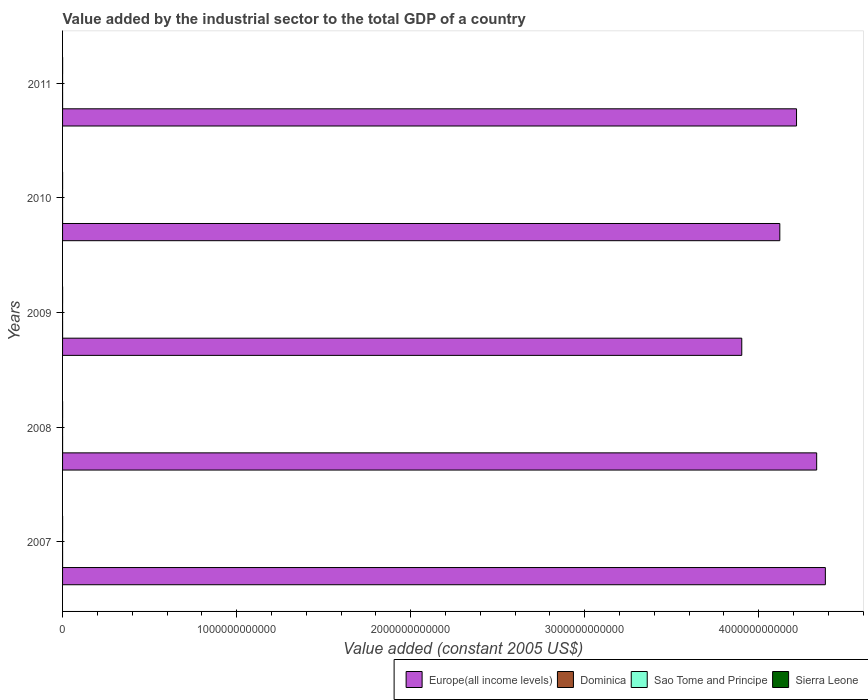How many different coloured bars are there?
Keep it short and to the point. 4. How many groups of bars are there?
Make the answer very short. 5. Are the number of bars per tick equal to the number of legend labels?
Make the answer very short. Yes. How many bars are there on the 3rd tick from the top?
Your response must be concise. 4. What is the label of the 4th group of bars from the top?
Your response must be concise. 2008. In how many cases, is the number of bars for a given year not equal to the number of legend labels?
Offer a terse response. 0. What is the value added by the industrial sector in Sao Tome and Principe in 2007?
Ensure brevity in your answer.  2.07e+07. Across all years, what is the maximum value added by the industrial sector in Europe(all income levels)?
Your answer should be compact. 4.38e+12. Across all years, what is the minimum value added by the industrial sector in Sao Tome and Principe?
Your response must be concise. 2.07e+07. In which year was the value added by the industrial sector in Europe(all income levels) maximum?
Offer a very short reply. 2007. In which year was the value added by the industrial sector in Dominica minimum?
Make the answer very short. 2009. What is the total value added by the industrial sector in Sierra Leone in the graph?
Offer a very short reply. 9.48e+08. What is the difference between the value added by the industrial sector in Europe(all income levels) in 2008 and that in 2011?
Give a very brief answer. 1.16e+11. What is the difference between the value added by the industrial sector in Europe(all income levels) in 2009 and the value added by the industrial sector in Dominica in 2008?
Keep it short and to the point. 3.90e+12. What is the average value added by the industrial sector in Europe(all income levels) per year?
Provide a succinct answer. 4.19e+12. In the year 2008, what is the difference between the value added by the industrial sector in Sao Tome and Principe and value added by the industrial sector in Sierra Leone?
Keep it short and to the point. -1.58e+08. What is the ratio of the value added by the industrial sector in Sao Tome and Principe in 2009 to that in 2010?
Your answer should be very brief. 0.98. Is the value added by the industrial sector in Sierra Leone in 2008 less than that in 2011?
Your response must be concise. Yes. What is the difference between the highest and the second highest value added by the industrial sector in Europe(all income levels)?
Your answer should be compact. 4.99e+1. What is the difference between the highest and the lowest value added by the industrial sector in Dominica?
Make the answer very short. 4.72e+06. In how many years, is the value added by the industrial sector in Europe(all income levels) greater than the average value added by the industrial sector in Europe(all income levels) taken over all years?
Give a very brief answer. 3. What does the 4th bar from the top in 2008 represents?
Your answer should be very brief. Europe(all income levels). What does the 4th bar from the bottom in 2008 represents?
Your answer should be compact. Sierra Leone. Is it the case that in every year, the sum of the value added by the industrial sector in Sao Tome and Principe and value added by the industrial sector in Europe(all income levels) is greater than the value added by the industrial sector in Sierra Leone?
Provide a short and direct response. Yes. How many bars are there?
Your response must be concise. 20. What is the difference between two consecutive major ticks on the X-axis?
Offer a terse response. 1.00e+12. Does the graph contain grids?
Give a very brief answer. No. Where does the legend appear in the graph?
Your response must be concise. Bottom right. How are the legend labels stacked?
Provide a succinct answer. Horizontal. What is the title of the graph?
Your response must be concise. Value added by the industrial sector to the total GDP of a country. Does "Barbados" appear as one of the legend labels in the graph?
Your response must be concise. No. What is the label or title of the X-axis?
Keep it short and to the point. Value added (constant 2005 US$). What is the label or title of the Y-axis?
Provide a short and direct response. Years. What is the Value added (constant 2005 US$) of Europe(all income levels) in 2007?
Your response must be concise. 4.38e+12. What is the Value added (constant 2005 US$) in Dominica in 2007?
Provide a succinct answer. 5.39e+07. What is the Value added (constant 2005 US$) of Sao Tome and Principe in 2007?
Your answer should be compact. 2.07e+07. What is the Value added (constant 2005 US$) of Sierra Leone in 2007?
Make the answer very short. 2.01e+08. What is the Value added (constant 2005 US$) of Europe(all income levels) in 2008?
Your response must be concise. 4.33e+12. What is the Value added (constant 2005 US$) in Dominica in 2008?
Your response must be concise. 5.82e+07. What is the Value added (constant 2005 US$) of Sao Tome and Principe in 2008?
Keep it short and to the point. 2.19e+07. What is the Value added (constant 2005 US$) of Sierra Leone in 2008?
Provide a succinct answer. 1.80e+08. What is the Value added (constant 2005 US$) of Europe(all income levels) in 2009?
Your response must be concise. 3.90e+12. What is the Value added (constant 2005 US$) in Dominica in 2009?
Your response must be concise. 5.35e+07. What is the Value added (constant 2005 US$) of Sao Tome and Principe in 2009?
Your response must be concise. 2.21e+07. What is the Value added (constant 2005 US$) of Sierra Leone in 2009?
Your response must be concise. 1.69e+08. What is the Value added (constant 2005 US$) in Europe(all income levels) in 2010?
Keep it short and to the point. 4.12e+12. What is the Value added (constant 2005 US$) in Dominica in 2010?
Offer a very short reply. 5.51e+07. What is the Value added (constant 2005 US$) of Sao Tome and Principe in 2010?
Your answer should be compact. 2.26e+07. What is the Value added (constant 2005 US$) in Sierra Leone in 2010?
Offer a very short reply. 1.89e+08. What is the Value added (constant 2005 US$) of Europe(all income levels) in 2011?
Your answer should be very brief. 4.22e+12. What is the Value added (constant 2005 US$) of Dominica in 2011?
Your answer should be very brief. 5.50e+07. What is the Value added (constant 2005 US$) in Sao Tome and Principe in 2011?
Offer a terse response. 2.38e+07. What is the Value added (constant 2005 US$) of Sierra Leone in 2011?
Ensure brevity in your answer.  2.09e+08. Across all years, what is the maximum Value added (constant 2005 US$) of Europe(all income levels)?
Keep it short and to the point. 4.38e+12. Across all years, what is the maximum Value added (constant 2005 US$) of Dominica?
Offer a very short reply. 5.82e+07. Across all years, what is the maximum Value added (constant 2005 US$) of Sao Tome and Principe?
Provide a succinct answer. 2.38e+07. Across all years, what is the maximum Value added (constant 2005 US$) in Sierra Leone?
Your response must be concise. 2.09e+08. Across all years, what is the minimum Value added (constant 2005 US$) of Europe(all income levels)?
Your answer should be compact. 3.90e+12. Across all years, what is the minimum Value added (constant 2005 US$) in Dominica?
Provide a succinct answer. 5.35e+07. Across all years, what is the minimum Value added (constant 2005 US$) of Sao Tome and Principe?
Keep it short and to the point. 2.07e+07. Across all years, what is the minimum Value added (constant 2005 US$) of Sierra Leone?
Give a very brief answer. 1.69e+08. What is the total Value added (constant 2005 US$) of Europe(all income levels) in the graph?
Offer a terse response. 2.10e+13. What is the total Value added (constant 2005 US$) of Dominica in the graph?
Offer a very short reply. 2.76e+08. What is the total Value added (constant 2005 US$) in Sao Tome and Principe in the graph?
Your answer should be compact. 1.11e+08. What is the total Value added (constant 2005 US$) in Sierra Leone in the graph?
Keep it short and to the point. 9.48e+08. What is the difference between the Value added (constant 2005 US$) of Europe(all income levels) in 2007 and that in 2008?
Offer a terse response. 4.99e+1. What is the difference between the Value added (constant 2005 US$) of Dominica in 2007 and that in 2008?
Offer a very short reply. -4.34e+06. What is the difference between the Value added (constant 2005 US$) of Sao Tome and Principe in 2007 and that in 2008?
Provide a succinct answer. -1.21e+06. What is the difference between the Value added (constant 2005 US$) in Sierra Leone in 2007 and that in 2008?
Give a very brief answer. 2.08e+07. What is the difference between the Value added (constant 2005 US$) in Europe(all income levels) in 2007 and that in 2009?
Make the answer very short. 4.80e+11. What is the difference between the Value added (constant 2005 US$) in Dominica in 2007 and that in 2009?
Provide a short and direct response. 3.71e+05. What is the difference between the Value added (constant 2005 US$) of Sao Tome and Principe in 2007 and that in 2009?
Give a very brief answer. -1.36e+06. What is the difference between the Value added (constant 2005 US$) of Sierra Leone in 2007 and that in 2009?
Make the answer very short. 3.24e+07. What is the difference between the Value added (constant 2005 US$) of Europe(all income levels) in 2007 and that in 2010?
Offer a very short reply. 2.62e+11. What is the difference between the Value added (constant 2005 US$) of Dominica in 2007 and that in 2010?
Offer a very short reply. -1.17e+06. What is the difference between the Value added (constant 2005 US$) of Sao Tome and Principe in 2007 and that in 2010?
Offer a terse response. -1.87e+06. What is the difference between the Value added (constant 2005 US$) in Sierra Leone in 2007 and that in 2010?
Offer a terse response. 1.17e+07. What is the difference between the Value added (constant 2005 US$) of Europe(all income levels) in 2007 and that in 2011?
Your answer should be compact. 1.66e+11. What is the difference between the Value added (constant 2005 US$) of Dominica in 2007 and that in 2011?
Offer a terse response. -1.12e+06. What is the difference between the Value added (constant 2005 US$) of Sao Tome and Principe in 2007 and that in 2011?
Make the answer very short. -3.09e+06. What is the difference between the Value added (constant 2005 US$) of Sierra Leone in 2007 and that in 2011?
Keep it short and to the point. -7.69e+06. What is the difference between the Value added (constant 2005 US$) of Europe(all income levels) in 2008 and that in 2009?
Your answer should be compact. 4.30e+11. What is the difference between the Value added (constant 2005 US$) in Dominica in 2008 and that in 2009?
Your answer should be compact. 4.72e+06. What is the difference between the Value added (constant 2005 US$) of Sao Tome and Principe in 2008 and that in 2009?
Make the answer very short. -1.52e+05. What is the difference between the Value added (constant 2005 US$) in Sierra Leone in 2008 and that in 2009?
Your answer should be very brief. 1.16e+07. What is the difference between the Value added (constant 2005 US$) in Europe(all income levels) in 2008 and that in 2010?
Your answer should be compact. 2.12e+11. What is the difference between the Value added (constant 2005 US$) in Dominica in 2008 and that in 2010?
Your answer should be compact. 3.18e+06. What is the difference between the Value added (constant 2005 US$) in Sao Tome and Principe in 2008 and that in 2010?
Provide a short and direct response. -6.63e+05. What is the difference between the Value added (constant 2005 US$) in Sierra Leone in 2008 and that in 2010?
Provide a succinct answer. -9.16e+06. What is the difference between the Value added (constant 2005 US$) in Europe(all income levels) in 2008 and that in 2011?
Your answer should be compact. 1.16e+11. What is the difference between the Value added (constant 2005 US$) in Dominica in 2008 and that in 2011?
Your response must be concise. 3.23e+06. What is the difference between the Value added (constant 2005 US$) in Sao Tome and Principe in 2008 and that in 2011?
Offer a very short reply. -1.88e+06. What is the difference between the Value added (constant 2005 US$) of Sierra Leone in 2008 and that in 2011?
Offer a very short reply. -2.85e+07. What is the difference between the Value added (constant 2005 US$) of Europe(all income levels) in 2009 and that in 2010?
Make the answer very short. -2.19e+11. What is the difference between the Value added (constant 2005 US$) of Dominica in 2009 and that in 2010?
Your response must be concise. -1.54e+06. What is the difference between the Value added (constant 2005 US$) of Sao Tome and Principe in 2009 and that in 2010?
Offer a very short reply. -5.12e+05. What is the difference between the Value added (constant 2005 US$) in Sierra Leone in 2009 and that in 2010?
Make the answer very short. -2.08e+07. What is the difference between the Value added (constant 2005 US$) in Europe(all income levels) in 2009 and that in 2011?
Provide a succinct answer. -3.15e+11. What is the difference between the Value added (constant 2005 US$) in Dominica in 2009 and that in 2011?
Offer a very short reply. -1.49e+06. What is the difference between the Value added (constant 2005 US$) of Sao Tome and Principe in 2009 and that in 2011?
Make the answer very short. -1.72e+06. What is the difference between the Value added (constant 2005 US$) of Sierra Leone in 2009 and that in 2011?
Ensure brevity in your answer.  -4.01e+07. What is the difference between the Value added (constant 2005 US$) in Europe(all income levels) in 2010 and that in 2011?
Offer a very short reply. -9.60e+1. What is the difference between the Value added (constant 2005 US$) in Dominica in 2010 and that in 2011?
Provide a succinct answer. 5.16e+04. What is the difference between the Value added (constant 2005 US$) in Sao Tome and Principe in 2010 and that in 2011?
Your answer should be very brief. -1.21e+06. What is the difference between the Value added (constant 2005 US$) in Sierra Leone in 2010 and that in 2011?
Keep it short and to the point. -1.94e+07. What is the difference between the Value added (constant 2005 US$) in Europe(all income levels) in 2007 and the Value added (constant 2005 US$) in Dominica in 2008?
Make the answer very short. 4.38e+12. What is the difference between the Value added (constant 2005 US$) of Europe(all income levels) in 2007 and the Value added (constant 2005 US$) of Sao Tome and Principe in 2008?
Offer a very short reply. 4.38e+12. What is the difference between the Value added (constant 2005 US$) in Europe(all income levels) in 2007 and the Value added (constant 2005 US$) in Sierra Leone in 2008?
Your answer should be compact. 4.38e+12. What is the difference between the Value added (constant 2005 US$) in Dominica in 2007 and the Value added (constant 2005 US$) in Sao Tome and Principe in 2008?
Offer a terse response. 3.20e+07. What is the difference between the Value added (constant 2005 US$) of Dominica in 2007 and the Value added (constant 2005 US$) of Sierra Leone in 2008?
Make the answer very short. -1.26e+08. What is the difference between the Value added (constant 2005 US$) in Sao Tome and Principe in 2007 and the Value added (constant 2005 US$) in Sierra Leone in 2008?
Keep it short and to the point. -1.59e+08. What is the difference between the Value added (constant 2005 US$) in Europe(all income levels) in 2007 and the Value added (constant 2005 US$) in Dominica in 2009?
Your answer should be very brief. 4.38e+12. What is the difference between the Value added (constant 2005 US$) in Europe(all income levels) in 2007 and the Value added (constant 2005 US$) in Sao Tome and Principe in 2009?
Offer a terse response. 4.38e+12. What is the difference between the Value added (constant 2005 US$) in Europe(all income levels) in 2007 and the Value added (constant 2005 US$) in Sierra Leone in 2009?
Provide a succinct answer. 4.38e+12. What is the difference between the Value added (constant 2005 US$) in Dominica in 2007 and the Value added (constant 2005 US$) in Sao Tome and Principe in 2009?
Offer a terse response. 3.18e+07. What is the difference between the Value added (constant 2005 US$) in Dominica in 2007 and the Value added (constant 2005 US$) in Sierra Leone in 2009?
Your answer should be very brief. -1.15e+08. What is the difference between the Value added (constant 2005 US$) of Sao Tome and Principe in 2007 and the Value added (constant 2005 US$) of Sierra Leone in 2009?
Provide a short and direct response. -1.48e+08. What is the difference between the Value added (constant 2005 US$) of Europe(all income levels) in 2007 and the Value added (constant 2005 US$) of Dominica in 2010?
Your answer should be compact. 4.38e+12. What is the difference between the Value added (constant 2005 US$) of Europe(all income levels) in 2007 and the Value added (constant 2005 US$) of Sao Tome and Principe in 2010?
Offer a very short reply. 4.38e+12. What is the difference between the Value added (constant 2005 US$) of Europe(all income levels) in 2007 and the Value added (constant 2005 US$) of Sierra Leone in 2010?
Provide a succinct answer. 4.38e+12. What is the difference between the Value added (constant 2005 US$) in Dominica in 2007 and the Value added (constant 2005 US$) in Sao Tome and Principe in 2010?
Offer a terse response. 3.13e+07. What is the difference between the Value added (constant 2005 US$) of Dominica in 2007 and the Value added (constant 2005 US$) of Sierra Leone in 2010?
Keep it short and to the point. -1.35e+08. What is the difference between the Value added (constant 2005 US$) of Sao Tome and Principe in 2007 and the Value added (constant 2005 US$) of Sierra Leone in 2010?
Your response must be concise. -1.69e+08. What is the difference between the Value added (constant 2005 US$) in Europe(all income levels) in 2007 and the Value added (constant 2005 US$) in Dominica in 2011?
Provide a succinct answer. 4.38e+12. What is the difference between the Value added (constant 2005 US$) in Europe(all income levels) in 2007 and the Value added (constant 2005 US$) in Sao Tome and Principe in 2011?
Provide a short and direct response. 4.38e+12. What is the difference between the Value added (constant 2005 US$) of Europe(all income levels) in 2007 and the Value added (constant 2005 US$) of Sierra Leone in 2011?
Offer a terse response. 4.38e+12. What is the difference between the Value added (constant 2005 US$) of Dominica in 2007 and the Value added (constant 2005 US$) of Sao Tome and Principe in 2011?
Offer a terse response. 3.01e+07. What is the difference between the Value added (constant 2005 US$) of Dominica in 2007 and the Value added (constant 2005 US$) of Sierra Leone in 2011?
Your answer should be compact. -1.55e+08. What is the difference between the Value added (constant 2005 US$) of Sao Tome and Principe in 2007 and the Value added (constant 2005 US$) of Sierra Leone in 2011?
Your answer should be compact. -1.88e+08. What is the difference between the Value added (constant 2005 US$) of Europe(all income levels) in 2008 and the Value added (constant 2005 US$) of Dominica in 2009?
Your response must be concise. 4.33e+12. What is the difference between the Value added (constant 2005 US$) of Europe(all income levels) in 2008 and the Value added (constant 2005 US$) of Sao Tome and Principe in 2009?
Give a very brief answer. 4.33e+12. What is the difference between the Value added (constant 2005 US$) of Europe(all income levels) in 2008 and the Value added (constant 2005 US$) of Sierra Leone in 2009?
Ensure brevity in your answer.  4.33e+12. What is the difference between the Value added (constant 2005 US$) of Dominica in 2008 and the Value added (constant 2005 US$) of Sao Tome and Principe in 2009?
Provide a short and direct response. 3.62e+07. What is the difference between the Value added (constant 2005 US$) in Dominica in 2008 and the Value added (constant 2005 US$) in Sierra Leone in 2009?
Offer a terse response. -1.10e+08. What is the difference between the Value added (constant 2005 US$) of Sao Tome and Principe in 2008 and the Value added (constant 2005 US$) of Sierra Leone in 2009?
Keep it short and to the point. -1.47e+08. What is the difference between the Value added (constant 2005 US$) in Europe(all income levels) in 2008 and the Value added (constant 2005 US$) in Dominica in 2010?
Provide a short and direct response. 4.33e+12. What is the difference between the Value added (constant 2005 US$) in Europe(all income levels) in 2008 and the Value added (constant 2005 US$) in Sao Tome and Principe in 2010?
Your response must be concise. 4.33e+12. What is the difference between the Value added (constant 2005 US$) in Europe(all income levels) in 2008 and the Value added (constant 2005 US$) in Sierra Leone in 2010?
Keep it short and to the point. 4.33e+12. What is the difference between the Value added (constant 2005 US$) of Dominica in 2008 and the Value added (constant 2005 US$) of Sao Tome and Principe in 2010?
Make the answer very short. 3.57e+07. What is the difference between the Value added (constant 2005 US$) of Dominica in 2008 and the Value added (constant 2005 US$) of Sierra Leone in 2010?
Make the answer very short. -1.31e+08. What is the difference between the Value added (constant 2005 US$) in Sao Tome and Principe in 2008 and the Value added (constant 2005 US$) in Sierra Leone in 2010?
Provide a short and direct response. -1.67e+08. What is the difference between the Value added (constant 2005 US$) in Europe(all income levels) in 2008 and the Value added (constant 2005 US$) in Dominica in 2011?
Offer a very short reply. 4.33e+12. What is the difference between the Value added (constant 2005 US$) in Europe(all income levels) in 2008 and the Value added (constant 2005 US$) in Sao Tome and Principe in 2011?
Provide a succinct answer. 4.33e+12. What is the difference between the Value added (constant 2005 US$) of Europe(all income levels) in 2008 and the Value added (constant 2005 US$) of Sierra Leone in 2011?
Your answer should be compact. 4.33e+12. What is the difference between the Value added (constant 2005 US$) of Dominica in 2008 and the Value added (constant 2005 US$) of Sao Tome and Principe in 2011?
Provide a short and direct response. 3.44e+07. What is the difference between the Value added (constant 2005 US$) in Dominica in 2008 and the Value added (constant 2005 US$) in Sierra Leone in 2011?
Make the answer very short. -1.50e+08. What is the difference between the Value added (constant 2005 US$) of Sao Tome and Principe in 2008 and the Value added (constant 2005 US$) of Sierra Leone in 2011?
Your response must be concise. -1.87e+08. What is the difference between the Value added (constant 2005 US$) in Europe(all income levels) in 2009 and the Value added (constant 2005 US$) in Dominica in 2010?
Keep it short and to the point. 3.90e+12. What is the difference between the Value added (constant 2005 US$) of Europe(all income levels) in 2009 and the Value added (constant 2005 US$) of Sao Tome and Principe in 2010?
Keep it short and to the point. 3.90e+12. What is the difference between the Value added (constant 2005 US$) of Europe(all income levels) in 2009 and the Value added (constant 2005 US$) of Sierra Leone in 2010?
Your response must be concise. 3.90e+12. What is the difference between the Value added (constant 2005 US$) of Dominica in 2009 and the Value added (constant 2005 US$) of Sao Tome and Principe in 2010?
Provide a short and direct response. 3.09e+07. What is the difference between the Value added (constant 2005 US$) of Dominica in 2009 and the Value added (constant 2005 US$) of Sierra Leone in 2010?
Your answer should be very brief. -1.36e+08. What is the difference between the Value added (constant 2005 US$) of Sao Tome and Principe in 2009 and the Value added (constant 2005 US$) of Sierra Leone in 2010?
Your answer should be compact. -1.67e+08. What is the difference between the Value added (constant 2005 US$) of Europe(all income levels) in 2009 and the Value added (constant 2005 US$) of Dominica in 2011?
Offer a terse response. 3.90e+12. What is the difference between the Value added (constant 2005 US$) of Europe(all income levels) in 2009 and the Value added (constant 2005 US$) of Sao Tome and Principe in 2011?
Make the answer very short. 3.90e+12. What is the difference between the Value added (constant 2005 US$) of Europe(all income levels) in 2009 and the Value added (constant 2005 US$) of Sierra Leone in 2011?
Offer a very short reply. 3.90e+12. What is the difference between the Value added (constant 2005 US$) in Dominica in 2009 and the Value added (constant 2005 US$) in Sao Tome and Principe in 2011?
Your answer should be very brief. 2.97e+07. What is the difference between the Value added (constant 2005 US$) in Dominica in 2009 and the Value added (constant 2005 US$) in Sierra Leone in 2011?
Your response must be concise. -1.55e+08. What is the difference between the Value added (constant 2005 US$) in Sao Tome and Principe in 2009 and the Value added (constant 2005 US$) in Sierra Leone in 2011?
Make the answer very short. -1.87e+08. What is the difference between the Value added (constant 2005 US$) in Europe(all income levels) in 2010 and the Value added (constant 2005 US$) in Dominica in 2011?
Offer a very short reply. 4.12e+12. What is the difference between the Value added (constant 2005 US$) of Europe(all income levels) in 2010 and the Value added (constant 2005 US$) of Sao Tome and Principe in 2011?
Offer a very short reply. 4.12e+12. What is the difference between the Value added (constant 2005 US$) in Europe(all income levels) in 2010 and the Value added (constant 2005 US$) in Sierra Leone in 2011?
Provide a short and direct response. 4.12e+12. What is the difference between the Value added (constant 2005 US$) in Dominica in 2010 and the Value added (constant 2005 US$) in Sao Tome and Principe in 2011?
Your response must be concise. 3.13e+07. What is the difference between the Value added (constant 2005 US$) of Dominica in 2010 and the Value added (constant 2005 US$) of Sierra Leone in 2011?
Offer a terse response. -1.54e+08. What is the difference between the Value added (constant 2005 US$) in Sao Tome and Principe in 2010 and the Value added (constant 2005 US$) in Sierra Leone in 2011?
Give a very brief answer. -1.86e+08. What is the average Value added (constant 2005 US$) in Europe(all income levels) per year?
Provide a short and direct response. 4.19e+12. What is the average Value added (constant 2005 US$) of Dominica per year?
Offer a terse response. 5.52e+07. What is the average Value added (constant 2005 US$) in Sao Tome and Principe per year?
Ensure brevity in your answer.  2.22e+07. What is the average Value added (constant 2005 US$) in Sierra Leone per year?
Offer a very short reply. 1.90e+08. In the year 2007, what is the difference between the Value added (constant 2005 US$) in Europe(all income levels) and Value added (constant 2005 US$) in Dominica?
Your answer should be very brief. 4.38e+12. In the year 2007, what is the difference between the Value added (constant 2005 US$) of Europe(all income levels) and Value added (constant 2005 US$) of Sao Tome and Principe?
Your answer should be compact. 4.38e+12. In the year 2007, what is the difference between the Value added (constant 2005 US$) in Europe(all income levels) and Value added (constant 2005 US$) in Sierra Leone?
Make the answer very short. 4.38e+12. In the year 2007, what is the difference between the Value added (constant 2005 US$) of Dominica and Value added (constant 2005 US$) of Sao Tome and Principe?
Keep it short and to the point. 3.32e+07. In the year 2007, what is the difference between the Value added (constant 2005 US$) of Dominica and Value added (constant 2005 US$) of Sierra Leone?
Provide a short and direct response. -1.47e+08. In the year 2007, what is the difference between the Value added (constant 2005 US$) of Sao Tome and Principe and Value added (constant 2005 US$) of Sierra Leone?
Make the answer very short. -1.80e+08. In the year 2008, what is the difference between the Value added (constant 2005 US$) of Europe(all income levels) and Value added (constant 2005 US$) of Dominica?
Provide a succinct answer. 4.33e+12. In the year 2008, what is the difference between the Value added (constant 2005 US$) of Europe(all income levels) and Value added (constant 2005 US$) of Sao Tome and Principe?
Make the answer very short. 4.33e+12. In the year 2008, what is the difference between the Value added (constant 2005 US$) in Europe(all income levels) and Value added (constant 2005 US$) in Sierra Leone?
Give a very brief answer. 4.33e+12. In the year 2008, what is the difference between the Value added (constant 2005 US$) in Dominica and Value added (constant 2005 US$) in Sao Tome and Principe?
Provide a short and direct response. 3.63e+07. In the year 2008, what is the difference between the Value added (constant 2005 US$) in Dominica and Value added (constant 2005 US$) in Sierra Leone?
Your answer should be very brief. -1.22e+08. In the year 2008, what is the difference between the Value added (constant 2005 US$) of Sao Tome and Principe and Value added (constant 2005 US$) of Sierra Leone?
Provide a succinct answer. -1.58e+08. In the year 2009, what is the difference between the Value added (constant 2005 US$) in Europe(all income levels) and Value added (constant 2005 US$) in Dominica?
Your answer should be very brief. 3.90e+12. In the year 2009, what is the difference between the Value added (constant 2005 US$) in Europe(all income levels) and Value added (constant 2005 US$) in Sao Tome and Principe?
Make the answer very short. 3.90e+12. In the year 2009, what is the difference between the Value added (constant 2005 US$) of Europe(all income levels) and Value added (constant 2005 US$) of Sierra Leone?
Your response must be concise. 3.90e+12. In the year 2009, what is the difference between the Value added (constant 2005 US$) of Dominica and Value added (constant 2005 US$) of Sao Tome and Principe?
Keep it short and to the point. 3.15e+07. In the year 2009, what is the difference between the Value added (constant 2005 US$) of Dominica and Value added (constant 2005 US$) of Sierra Leone?
Offer a very short reply. -1.15e+08. In the year 2009, what is the difference between the Value added (constant 2005 US$) in Sao Tome and Principe and Value added (constant 2005 US$) in Sierra Leone?
Ensure brevity in your answer.  -1.47e+08. In the year 2010, what is the difference between the Value added (constant 2005 US$) in Europe(all income levels) and Value added (constant 2005 US$) in Dominica?
Offer a very short reply. 4.12e+12. In the year 2010, what is the difference between the Value added (constant 2005 US$) of Europe(all income levels) and Value added (constant 2005 US$) of Sao Tome and Principe?
Make the answer very short. 4.12e+12. In the year 2010, what is the difference between the Value added (constant 2005 US$) of Europe(all income levels) and Value added (constant 2005 US$) of Sierra Leone?
Ensure brevity in your answer.  4.12e+12. In the year 2010, what is the difference between the Value added (constant 2005 US$) of Dominica and Value added (constant 2005 US$) of Sao Tome and Principe?
Offer a terse response. 3.25e+07. In the year 2010, what is the difference between the Value added (constant 2005 US$) of Dominica and Value added (constant 2005 US$) of Sierra Leone?
Provide a short and direct response. -1.34e+08. In the year 2010, what is the difference between the Value added (constant 2005 US$) in Sao Tome and Principe and Value added (constant 2005 US$) in Sierra Leone?
Offer a very short reply. -1.67e+08. In the year 2011, what is the difference between the Value added (constant 2005 US$) in Europe(all income levels) and Value added (constant 2005 US$) in Dominica?
Give a very brief answer. 4.22e+12. In the year 2011, what is the difference between the Value added (constant 2005 US$) of Europe(all income levels) and Value added (constant 2005 US$) of Sao Tome and Principe?
Your answer should be very brief. 4.22e+12. In the year 2011, what is the difference between the Value added (constant 2005 US$) in Europe(all income levels) and Value added (constant 2005 US$) in Sierra Leone?
Ensure brevity in your answer.  4.22e+12. In the year 2011, what is the difference between the Value added (constant 2005 US$) of Dominica and Value added (constant 2005 US$) of Sao Tome and Principe?
Your answer should be compact. 3.12e+07. In the year 2011, what is the difference between the Value added (constant 2005 US$) of Dominica and Value added (constant 2005 US$) of Sierra Leone?
Provide a short and direct response. -1.54e+08. In the year 2011, what is the difference between the Value added (constant 2005 US$) in Sao Tome and Principe and Value added (constant 2005 US$) in Sierra Leone?
Ensure brevity in your answer.  -1.85e+08. What is the ratio of the Value added (constant 2005 US$) of Europe(all income levels) in 2007 to that in 2008?
Your answer should be very brief. 1.01. What is the ratio of the Value added (constant 2005 US$) in Dominica in 2007 to that in 2008?
Give a very brief answer. 0.93. What is the ratio of the Value added (constant 2005 US$) in Sao Tome and Principe in 2007 to that in 2008?
Your response must be concise. 0.94. What is the ratio of the Value added (constant 2005 US$) in Sierra Leone in 2007 to that in 2008?
Offer a very short reply. 1.12. What is the ratio of the Value added (constant 2005 US$) in Europe(all income levels) in 2007 to that in 2009?
Offer a terse response. 1.12. What is the ratio of the Value added (constant 2005 US$) of Dominica in 2007 to that in 2009?
Make the answer very short. 1.01. What is the ratio of the Value added (constant 2005 US$) of Sao Tome and Principe in 2007 to that in 2009?
Ensure brevity in your answer.  0.94. What is the ratio of the Value added (constant 2005 US$) of Sierra Leone in 2007 to that in 2009?
Offer a terse response. 1.19. What is the ratio of the Value added (constant 2005 US$) of Europe(all income levels) in 2007 to that in 2010?
Your response must be concise. 1.06. What is the ratio of the Value added (constant 2005 US$) of Dominica in 2007 to that in 2010?
Your response must be concise. 0.98. What is the ratio of the Value added (constant 2005 US$) in Sao Tome and Principe in 2007 to that in 2010?
Offer a very short reply. 0.92. What is the ratio of the Value added (constant 2005 US$) in Sierra Leone in 2007 to that in 2010?
Make the answer very short. 1.06. What is the ratio of the Value added (constant 2005 US$) in Europe(all income levels) in 2007 to that in 2011?
Your response must be concise. 1.04. What is the ratio of the Value added (constant 2005 US$) in Dominica in 2007 to that in 2011?
Ensure brevity in your answer.  0.98. What is the ratio of the Value added (constant 2005 US$) of Sao Tome and Principe in 2007 to that in 2011?
Your answer should be very brief. 0.87. What is the ratio of the Value added (constant 2005 US$) of Sierra Leone in 2007 to that in 2011?
Make the answer very short. 0.96. What is the ratio of the Value added (constant 2005 US$) of Europe(all income levels) in 2008 to that in 2009?
Your response must be concise. 1.11. What is the ratio of the Value added (constant 2005 US$) of Dominica in 2008 to that in 2009?
Keep it short and to the point. 1.09. What is the ratio of the Value added (constant 2005 US$) in Sierra Leone in 2008 to that in 2009?
Your response must be concise. 1.07. What is the ratio of the Value added (constant 2005 US$) of Europe(all income levels) in 2008 to that in 2010?
Provide a succinct answer. 1.05. What is the ratio of the Value added (constant 2005 US$) in Dominica in 2008 to that in 2010?
Offer a terse response. 1.06. What is the ratio of the Value added (constant 2005 US$) in Sao Tome and Principe in 2008 to that in 2010?
Offer a very short reply. 0.97. What is the ratio of the Value added (constant 2005 US$) of Sierra Leone in 2008 to that in 2010?
Make the answer very short. 0.95. What is the ratio of the Value added (constant 2005 US$) of Europe(all income levels) in 2008 to that in 2011?
Offer a very short reply. 1.03. What is the ratio of the Value added (constant 2005 US$) of Dominica in 2008 to that in 2011?
Offer a terse response. 1.06. What is the ratio of the Value added (constant 2005 US$) of Sao Tome and Principe in 2008 to that in 2011?
Your answer should be very brief. 0.92. What is the ratio of the Value added (constant 2005 US$) of Sierra Leone in 2008 to that in 2011?
Ensure brevity in your answer.  0.86. What is the ratio of the Value added (constant 2005 US$) of Europe(all income levels) in 2009 to that in 2010?
Provide a short and direct response. 0.95. What is the ratio of the Value added (constant 2005 US$) in Dominica in 2009 to that in 2010?
Your answer should be very brief. 0.97. What is the ratio of the Value added (constant 2005 US$) in Sao Tome and Principe in 2009 to that in 2010?
Offer a terse response. 0.98. What is the ratio of the Value added (constant 2005 US$) of Sierra Leone in 2009 to that in 2010?
Offer a very short reply. 0.89. What is the ratio of the Value added (constant 2005 US$) of Europe(all income levels) in 2009 to that in 2011?
Offer a terse response. 0.93. What is the ratio of the Value added (constant 2005 US$) of Sao Tome and Principe in 2009 to that in 2011?
Your response must be concise. 0.93. What is the ratio of the Value added (constant 2005 US$) of Sierra Leone in 2009 to that in 2011?
Provide a short and direct response. 0.81. What is the ratio of the Value added (constant 2005 US$) in Europe(all income levels) in 2010 to that in 2011?
Provide a succinct answer. 0.98. What is the ratio of the Value added (constant 2005 US$) of Dominica in 2010 to that in 2011?
Your response must be concise. 1. What is the ratio of the Value added (constant 2005 US$) in Sao Tome and Principe in 2010 to that in 2011?
Ensure brevity in your answer.  0.95. What is the ratio of the Value added (constant 2005 US$) in Sierra Leone in 2010 to that in 2011?
Give a very brief answer. 0.91. What is the difference between the highest and the second highest Value added (constant 2005 US$) of Europe(all income levels)?
Keep it short and to the point. 4.99e+1. What is the difference between the highest and the second highest Value added (constant 2005 US$) of Dominica?
Provide a short and direct response. 3.18e+06. What is the difference between the highest and the second highest Value added (constant 2005 US$) of Sao Tome and Principe?
Keep it short and to the point. 1.21e+06. What is the difference between the highest and the second highest Value added (constant 2005 US$) in Sierra Leone?
Offer a terse response. 7.69e+06. What is the difference between the highest and the lowest Value added (constant 2005 US$) of Europe(all income levels)?
Ensure brevity in your answer.  4.80e+11. What is the difference between the highest and the lowest Value added (constant 2005 US$) in Dominica?
Keep it short and to the point. 4.72e+06. What is the difference between the highest and the lowest Value added (constant 2005 US$) of Sao Tome and Principe?
Provide a short and direct response. 3.09e+06. What is the difference between the highest and the lowest Value added (constant 2005 US$) in Sierra Leone?
Offer a very short reply. 4.01e+07. 